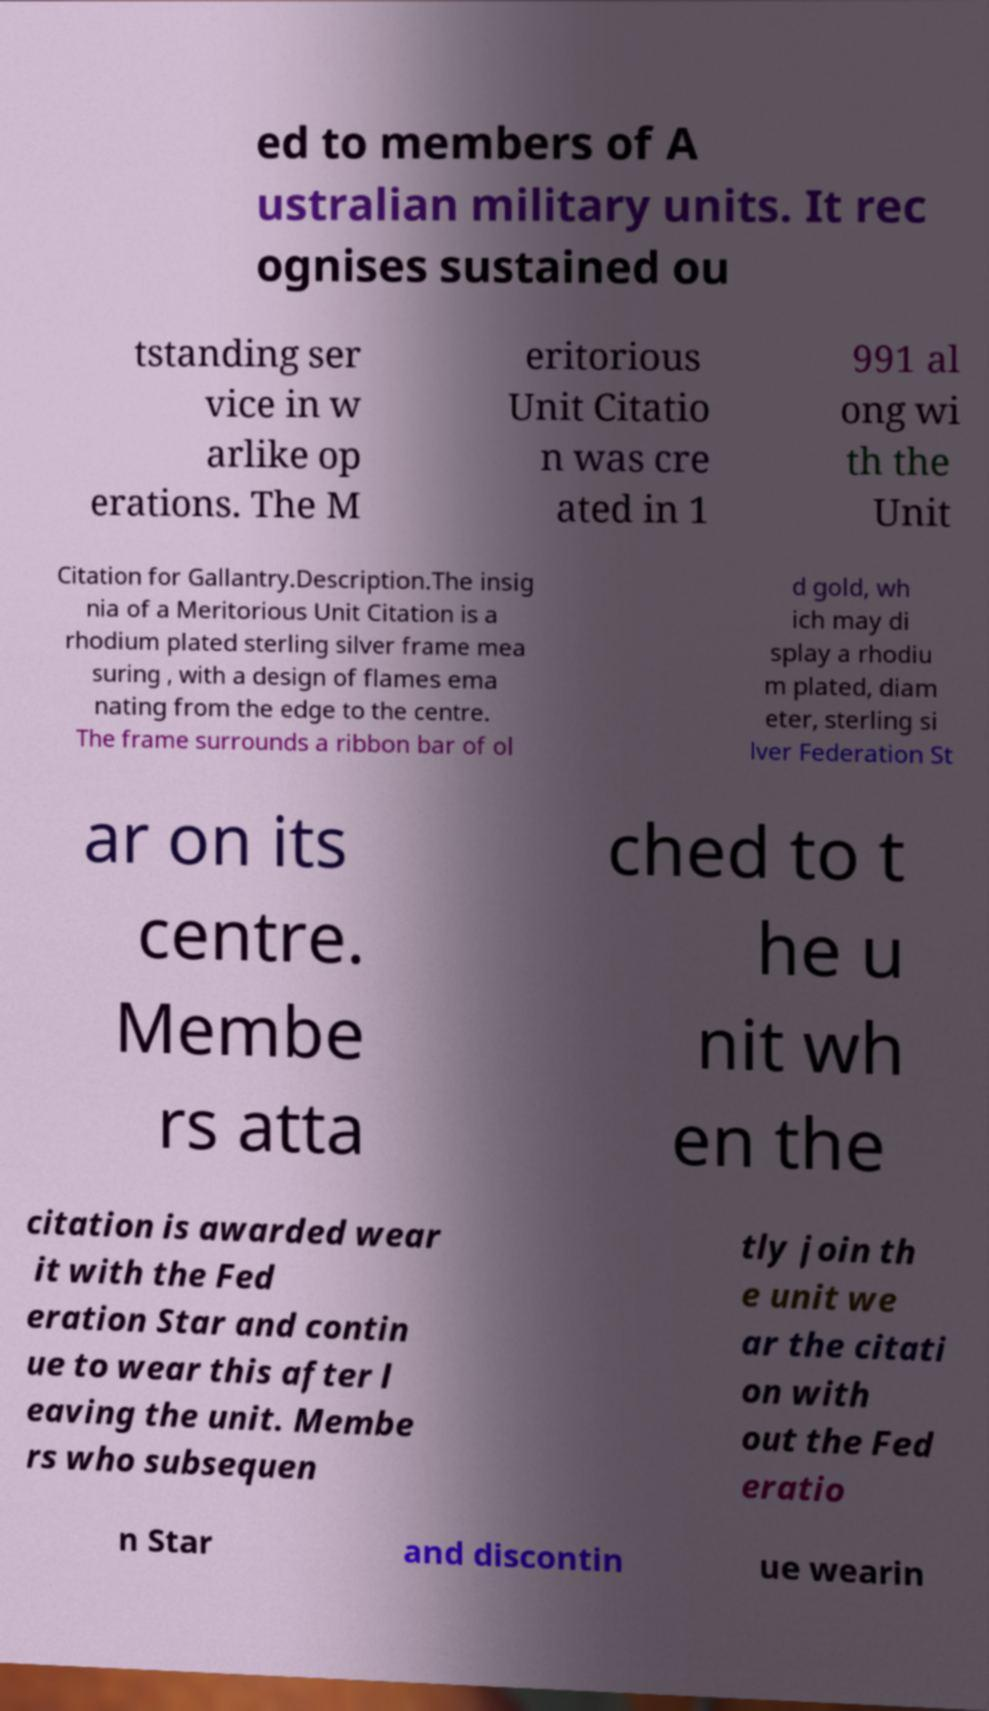There's text embedded in this image that I need extracted. Can you transcribe it verbatim? ed to members of A ustralian military units. It rec ognises sustained ou tstanding ser vice in w arlike op erations. The M eritorious Unit Citatio n was cre ated in 1 991 al ong wi th the Unit Citation for Gallantry.Description.The insig nia of a Meritorious Unit Citation is a rhodium plated sterling silver frame mea suring , with a design of flames ema nating from the edge to the centre. The frame surrounds a ribbon bar of ol d gold, wh ich may di splay a rhodiu m plated, diam eter, sterling si lver Federation St ar on its centre. Membe rs atta ched to t he u nit wh en the citation is awarded wear it with the Fed eration Star and contin ue to wear this after l eaving the unit. Membe rs who subsequen tly join th e unit we ar the citati on with out the Fed eratio n Star and discontin ue wearin 